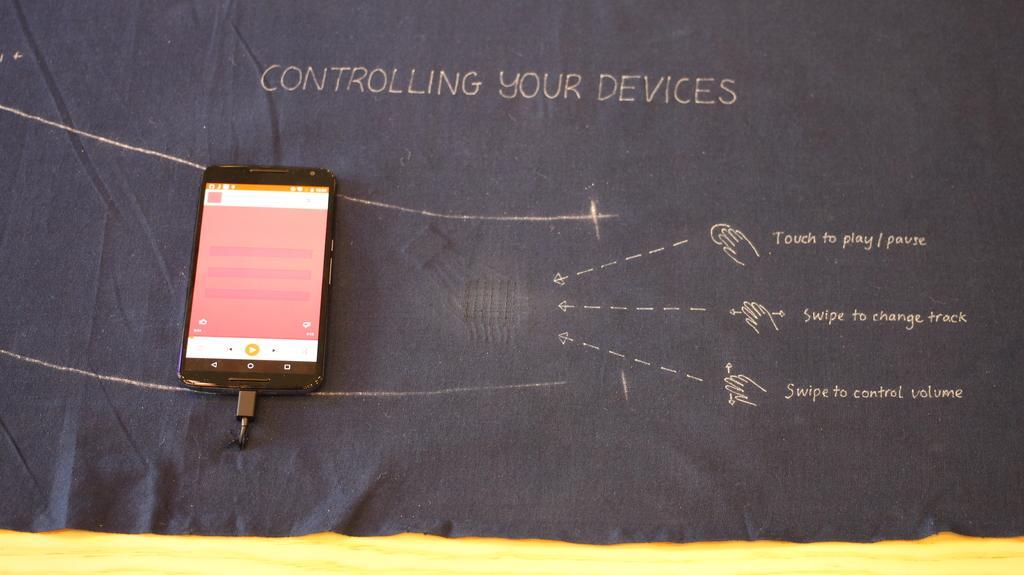<image>
Write a terse but informative summary of the picture. A diagram shows ways of controlling your devices, such as swipe to change track. 